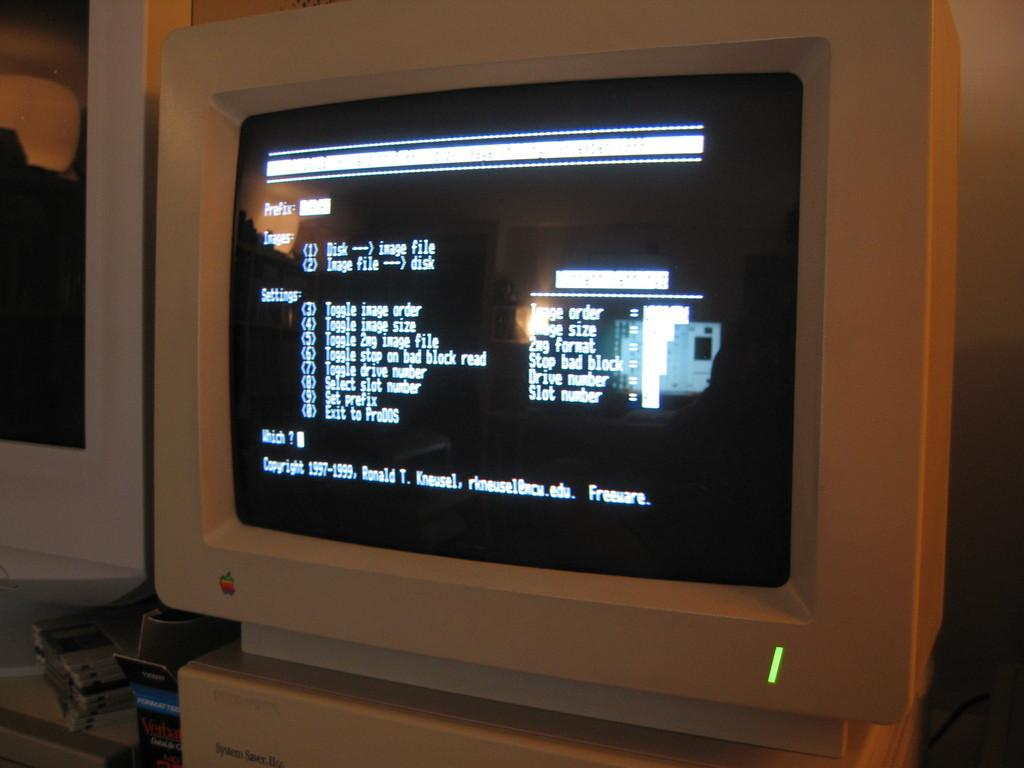<image>
Describe the image concisely. A old white Apple computer turned on with aa green power light . 